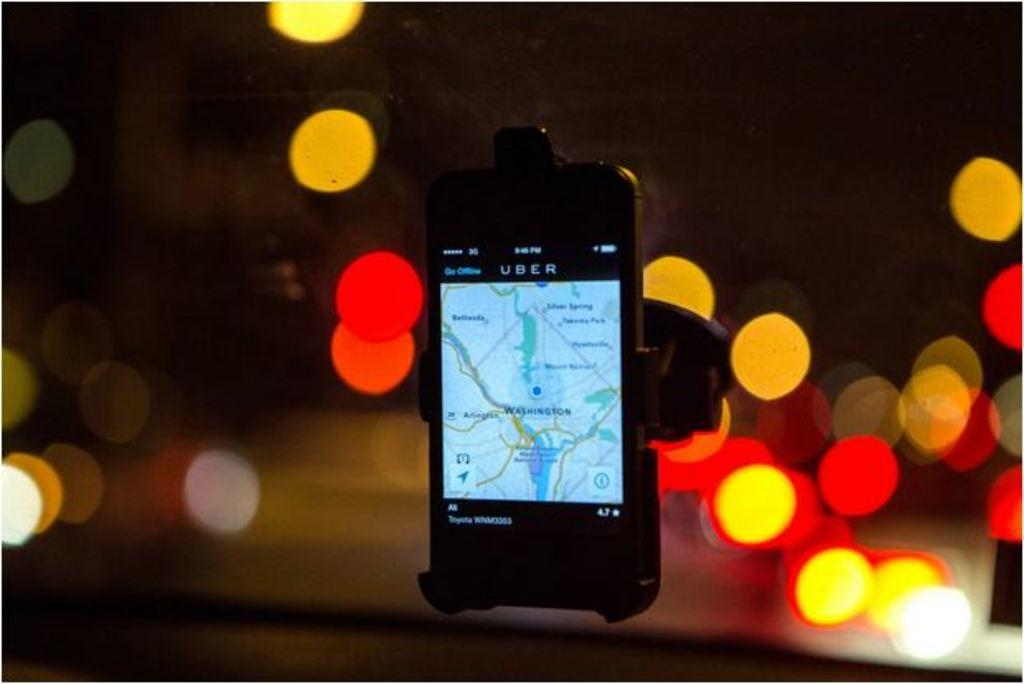<image>
Describe the image concisely. A phone is hanging on a windscreen showing an uber app. 